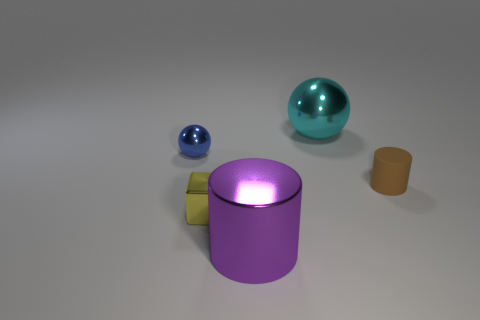Is there anything else that has the same material as the brown cylinder?
Make the answer very short. No. The blue sphere that is made of the same material as the small yellow object is what size?
Offer a very short reply. Small. What number of objects are big shiny objects in front of the cyan ball or objects to the left of the matte thing?
Offer a very short reply. 4. Are there an equal number of purple metal cylinders behind the small blue thing and large cyan things on the left side of the small yellow thing?
Give a very brief answer. Yes. There is a small metal thing that is right of the tiny blue shiny ball; what color is it?
Give a very brief answer. Yellow. Is the number of big purple cylinders less than the number of purple metal spheres?
Make the answer very short. No. How many purple metal cylinders are the same size as the cyan shiny thing?
Your response must be concise. 1. Is the tiny blue ball made of the same material as the small block?
Ensure brevity in your answer.  Yes. What number of other brown matte things have the same shape as the small brown matte thing?
Offer a terse response. 0. What is the shape of the cyan thing that is the same material as the tiny sphere?
Keep it short and to the point. Sphere. 